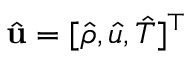<formula> <loc_0><loc_0><loc_500><loc_500>\hat { u } = [ \hat { \rho } , \hat { u } , \hat { T } ] ^ { \top }</formula> 